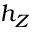Convert formula to latex. <formula><loc_0><loc_0><loc_500><loc_500>h _ { Z }</formula> 